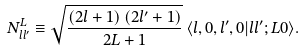Convert formula to latex. <formula><loc_0><loc_0><loc_500><loc_500>N ^ { L } _ { l l ^ { \prime } } \equiv \sqrt { \frac { \left ( 2 l + 1 \right ) \left ( 2 l ^ { \prime } + 1 \right ) } { 2 L + 1 } } \, \langle l , 0 , l ^ { \prime } , 0 | l l ^ { \prime } ; L 0 \rangle .</formula> 